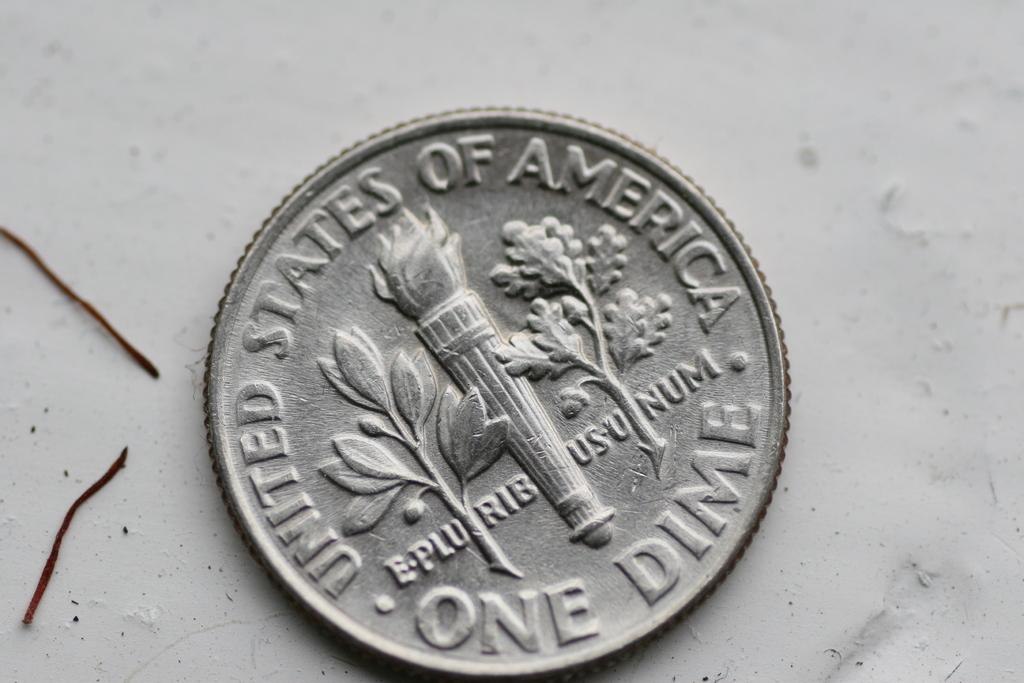<image>
Write a terse but informative summary of the picture. A coin has the words one dime imprinted on it. 